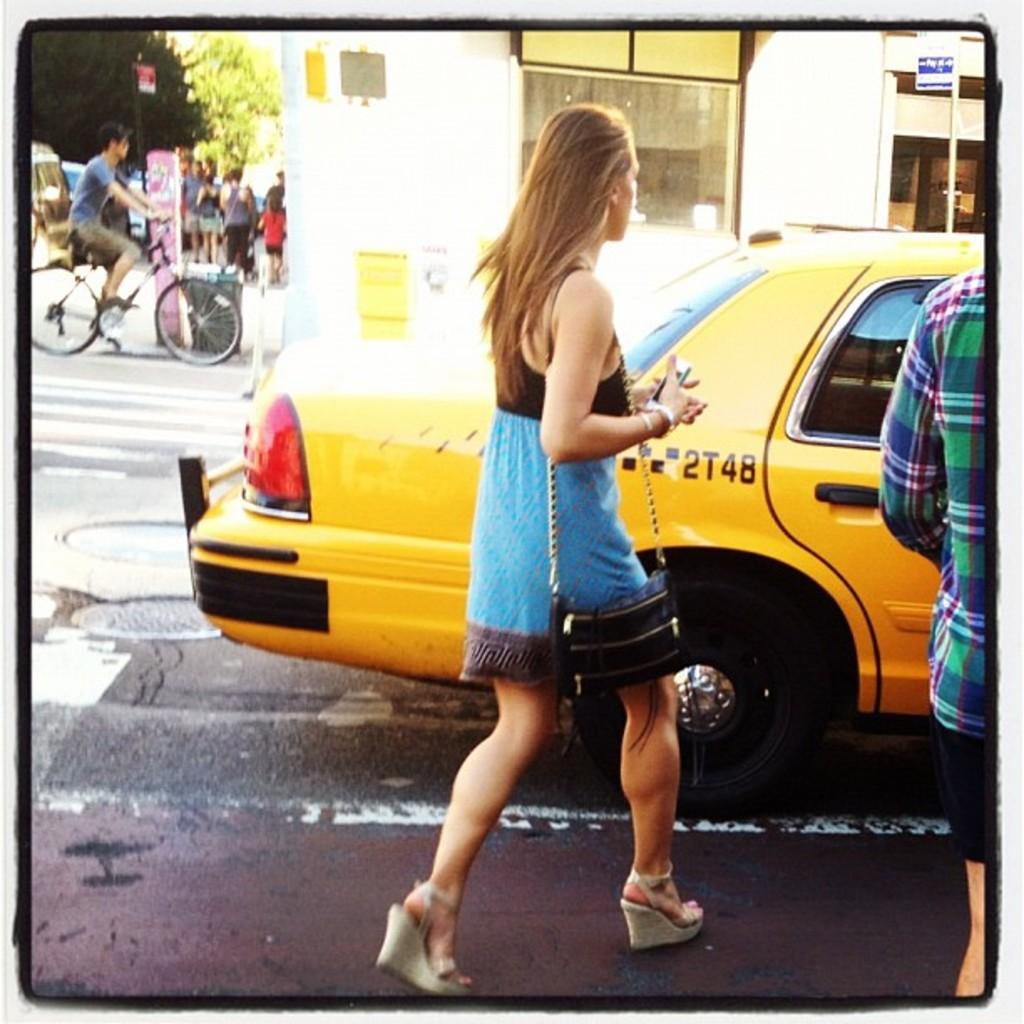<image>
Create a compact narrative representing the image presented. A woman walks over to a yellow cab labeled 2T4B. 